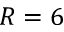<formula> <loc_0><loc_0><loc_500><loc_500>R = 6</formula> 